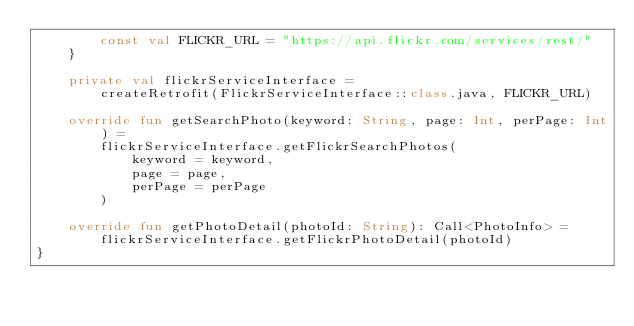<code> <loc_0><loc_0><loc_500><loc_500><_Kotlin_>        const val FLICKR_URL = "https://api.flickr.com/services/rest/"
    }

    private val flickrServiceInterface =
        createRetrofit(FlickrServiceInterface::class.java, FLICKR_URL)

    override fun getSearchPhoto(keyword: String, page: Int, perPage: Int) =
        flickrServiceInterface.getFlickrSearchPhotos(
            keyword = keyword,
            page = page,
            perPage = perPage
        )

    override fun getPhotoDetail(photoId: String): Call<PhotoInfo> =
        flickrServiceInterface.getFlickrPhotoDetail(photoId)
}</code> 